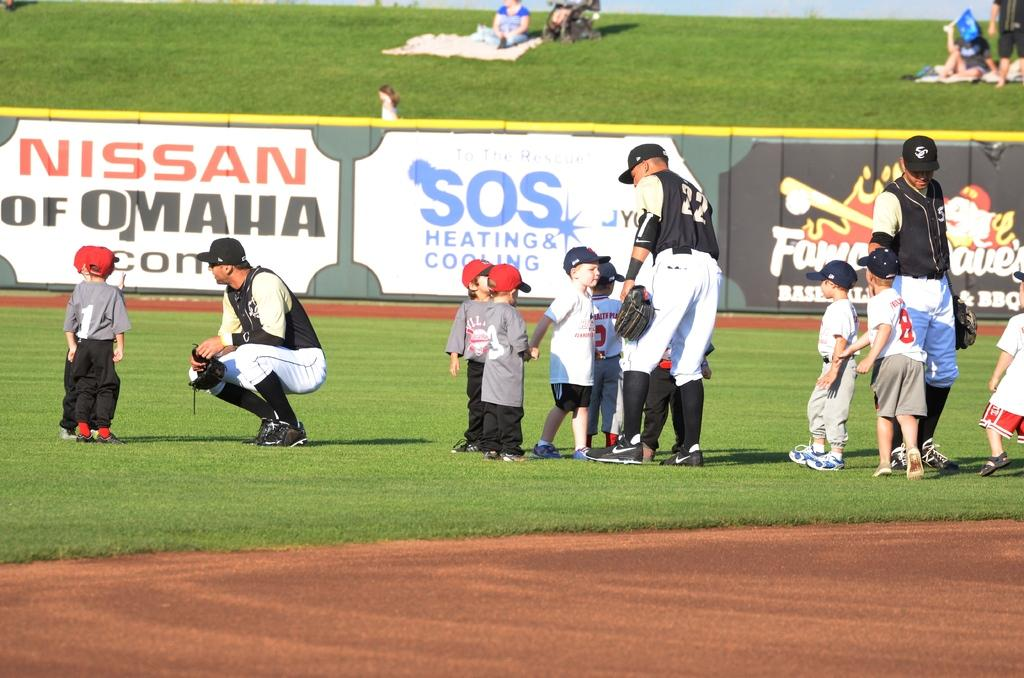<image>
Summarize the visual content of the image. Little boys mingle with an adult baseball team by a Nissan of Omaha banner. 